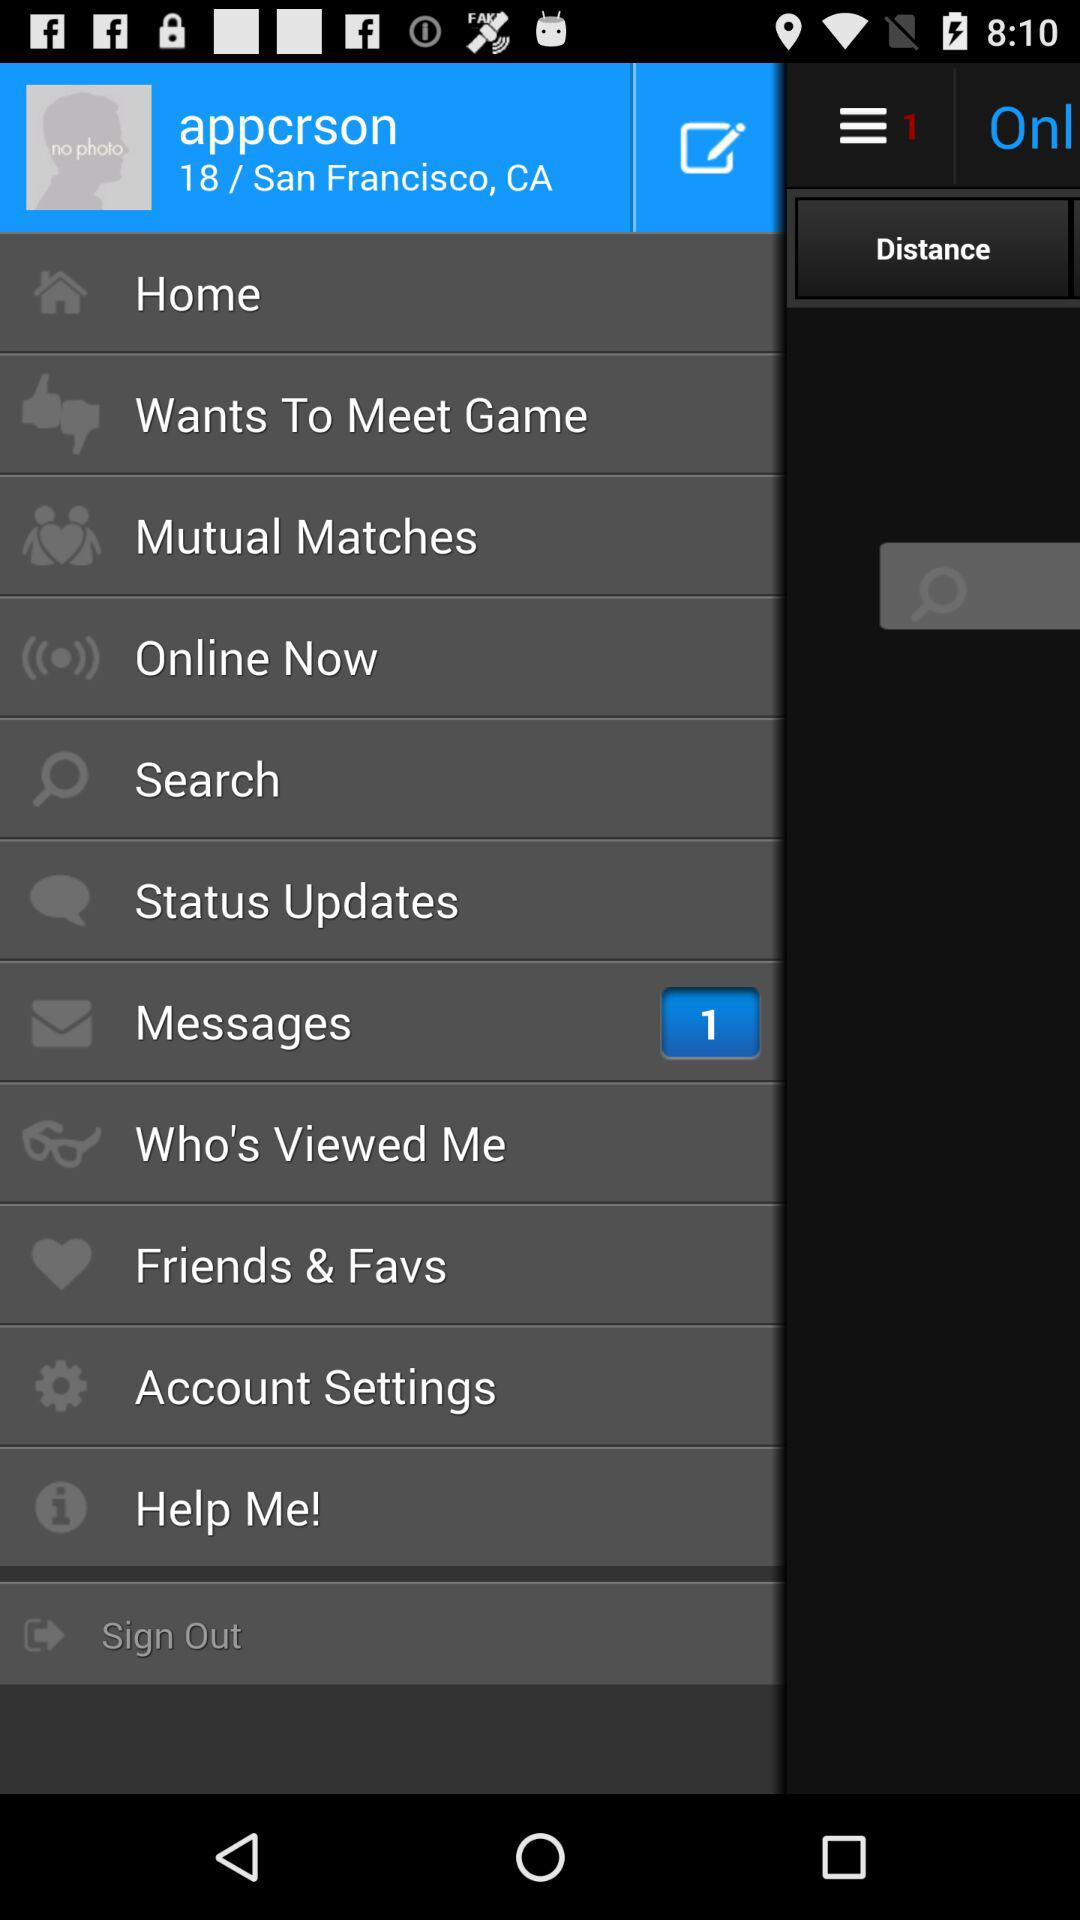Are there any unread messages? There is 1 unread message. 